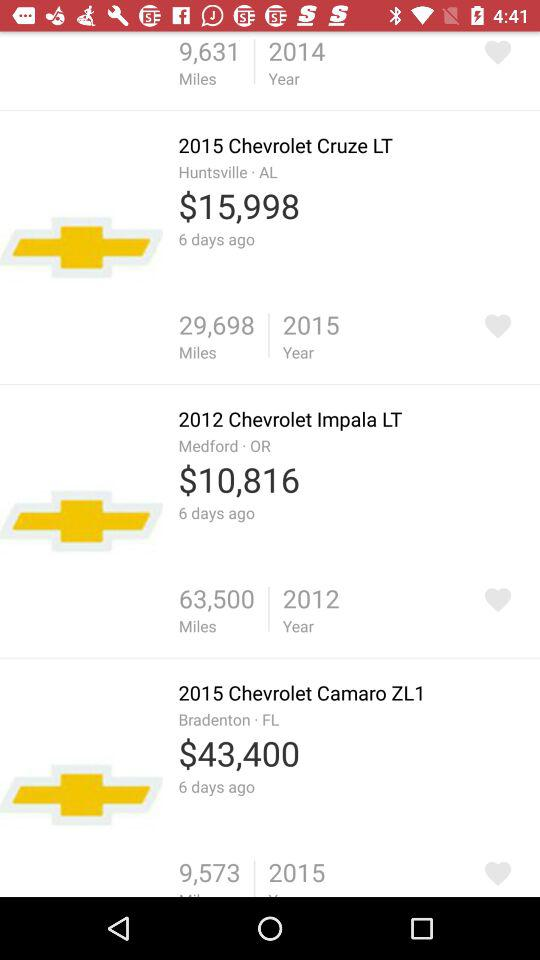What is the price of the "2015 Chevrolet Cruze LT"? The price of the "2015 Chevrolet Cruze LT" is $15,998. 